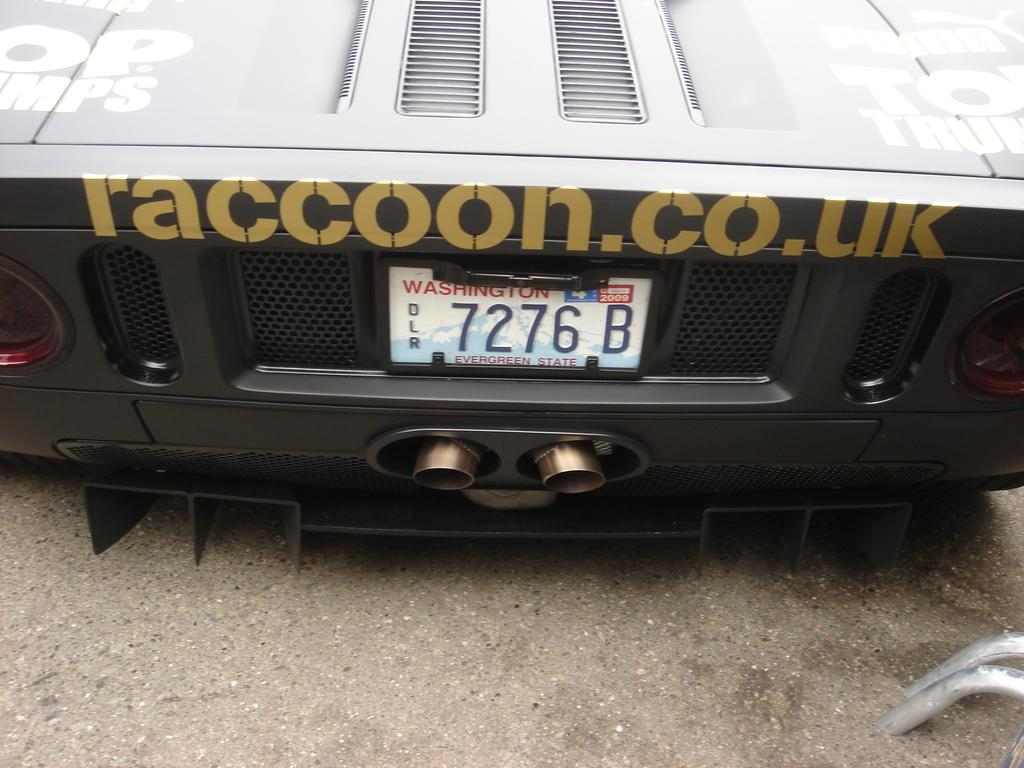What is the main subject of the image? The main subject of the image is a car. Are there any other objects or features visible in the image? Yes, there are metal rods at the right bottom of the image. What message of good-bye can be seen on the car in the image? There is no message of good-bye visible on the car in the image. 